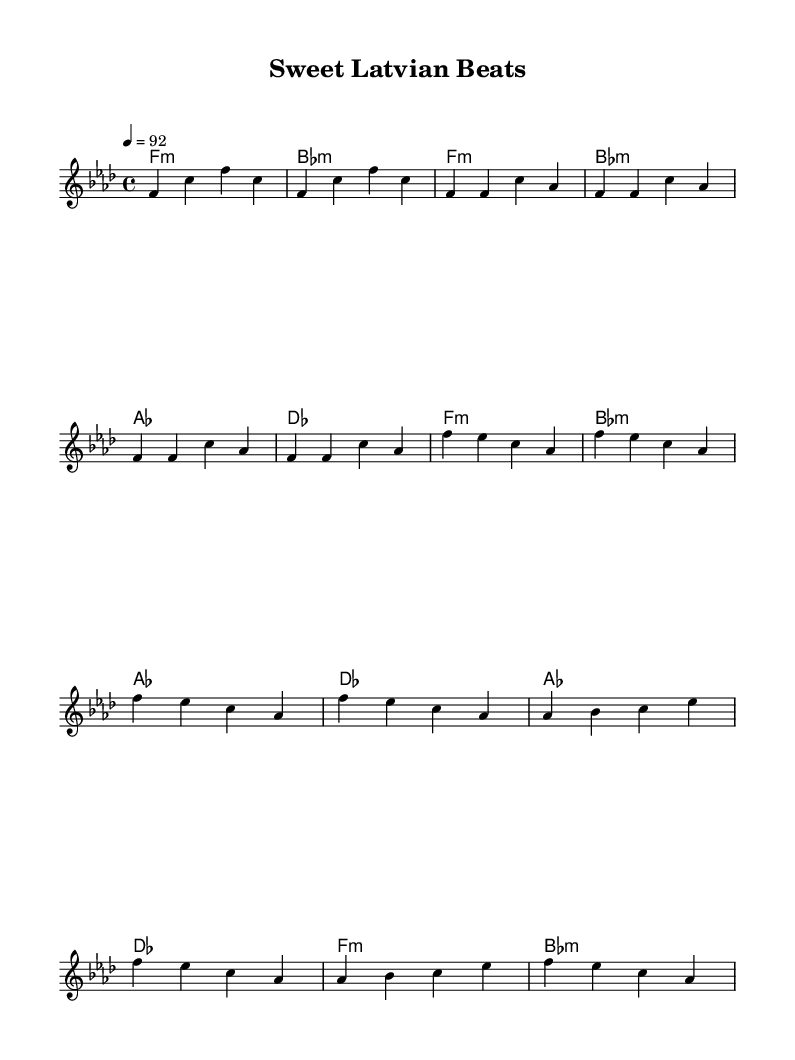What is the key signature of this music? The key signature is indicated at the beginning of the score. It shows one flat, which corresponds to F minor.
Answer: F minor What is the time signature of this music? The time signature is found at the start of the score, which indicates that each measure has four beats. This is represented as 4/4.
Answer: 4/4 What is the tempo marking for this piece? The tempo is specified by the number that shows the beats per minute, which is shown as a quarter note equaling 92.
Answer: 92 How many measures are there in the chorus section? The chorus section has a repeated pattern, with four measures shown in the score from the beginning of the chorus to its end. Each line of the chorus is two measures that repeat twice, totaling four.
Answer: Four Which musical section follows the verse? The sections are clearly delineated, and after the verse, the next section is labeled as the chorus, which comes next in the structure.
Answer: Chorus What chords are played during the bridge section? The chords during the bridge have a specific sequence outlined in the harmonies, which shows four chords played: A-flat, D-flat, F minor, and B-flat minor.
Answer: A-flat, D-flat, F minor, B-flat minor What is the main musical form used in this rap piece? Observing the structure, it alternates between verses and a chorus, which is a common form in rap music, characterized by repeated choruses after verses.
Answer: Verse-Chorus 